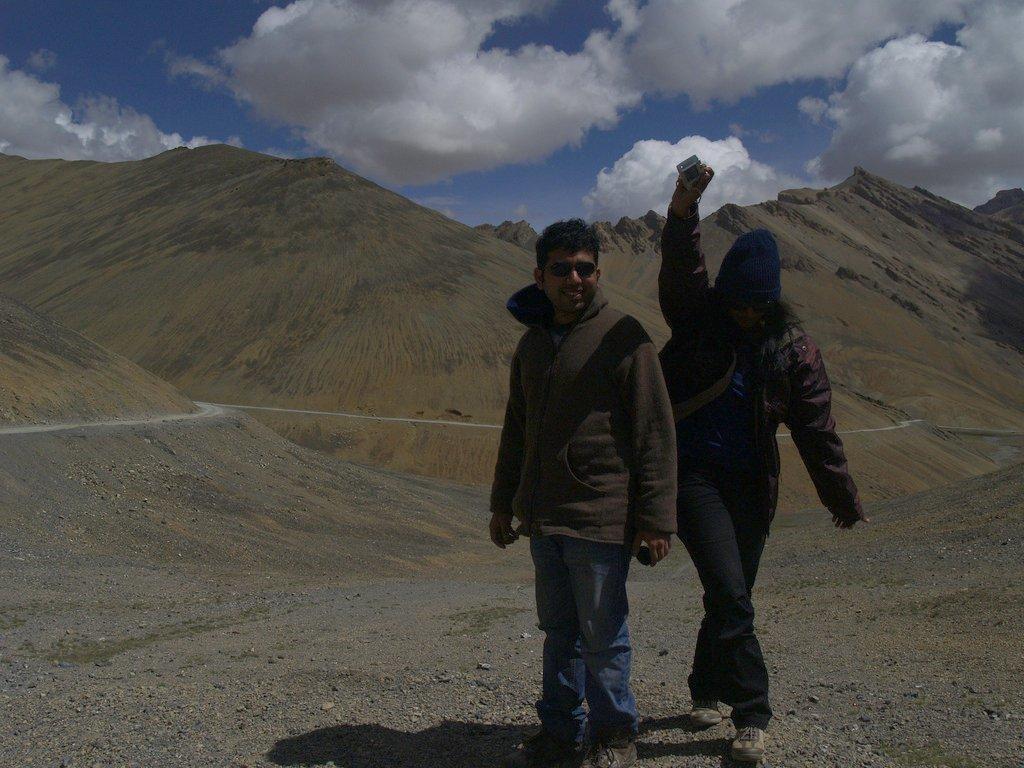Could you give a brief overview of what you see in this image? In this image there are two persons standing on the right side of this image and there are some mountains in the background. There is a cloudy sky on the top of this image. 